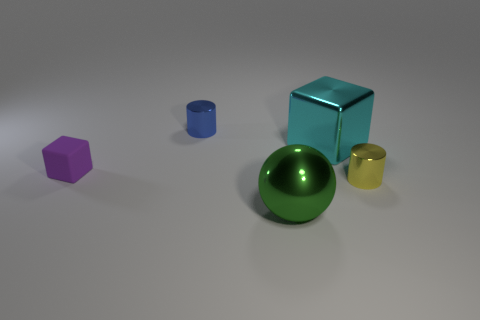There is a big shiny thing behind the purple matte block; what is its color?
Offer a very short reply. Cyan. There is a object that is right of the large metal object that is behind the small purple matte cube; is there a yellow thing that is to the left of it?
Your answer should be very brief. No. Is the number of small metal things that are in front of the large cyan thing greater than the number of big blue shiny balls?
Provide a succinct answer. Yes. Does the small object to the right of the tiny blue shiny cylinder have the same shape as the blue metal thing?
Provide a short and direct response. Yes. Are there any other things that are made of the same material as the tiny purple cube?
Provide a succinct answer. No. How many objects are small purple cubes or metal things to the right of the green thing?
Your answer should be compact. 3. There is a metal object that is behind the small purple thing and to the right of the big green metallic thing; what size is it?
Keep it short and to the point. Large. Is the number of rubber objects that are to the right of the large sphere greater than the number of tiny matte things to the left of the big cube?
Make the answer very short. No. Is the shape of the large cyan metal object the same as the small matte object that is left of the green metallic ball?
Your answer should be very brief. Yes. How many other objects are there of the same shape as the big green shiny object?
Your answer should be very brief. 0. 